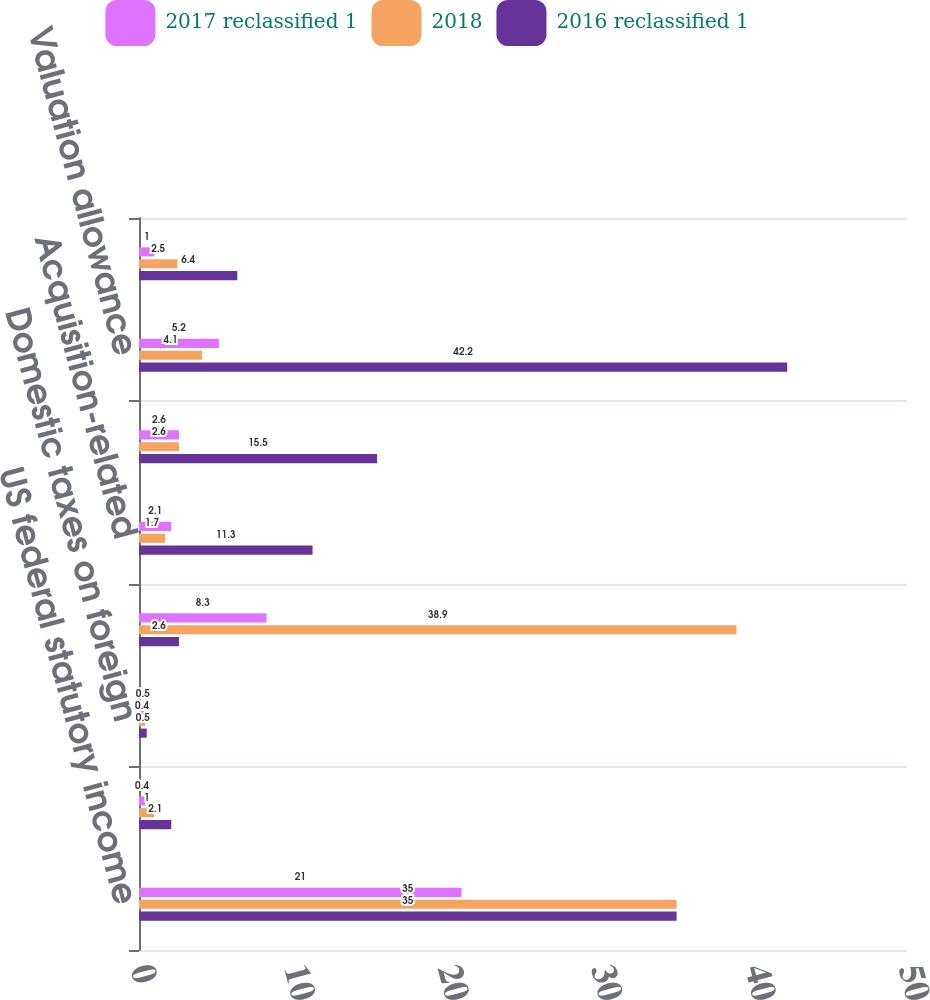<chart> <loc_0><loc_0><loc_500><loc_500><stacked_bar_chart><ecel><fcel>US federal statutory income<fcel>State income taxes net of<fcel>Domestic taxes on foreign<fcel>Effect of foreign taxes<fcel>Acquisition-related<fcel>Research credit<fcel>Valuation allowance<fcel>Compensation-related<nl><fcel>2017 reclassified 1<fcel>21<fcel>0.4<fcel>0.5<fcel>8.3<fcel>2.1<fcel>2.6<fcel>5.2<fcel>1<nl><fcel>2018<fcel>35<fcel>1<fcel>0.4<fcel>38.9<fcel>1.7<fcel>2.6<fcel>4.1<fcel>2.5<nl><fcel>2016 reclassified 1<fcel>35<fcel>2.1<fcel>0.5<fcel>2.6<fcel>11.3<fcel>15.5<fcel>42.2<fcel>6.4<nl></chart> 